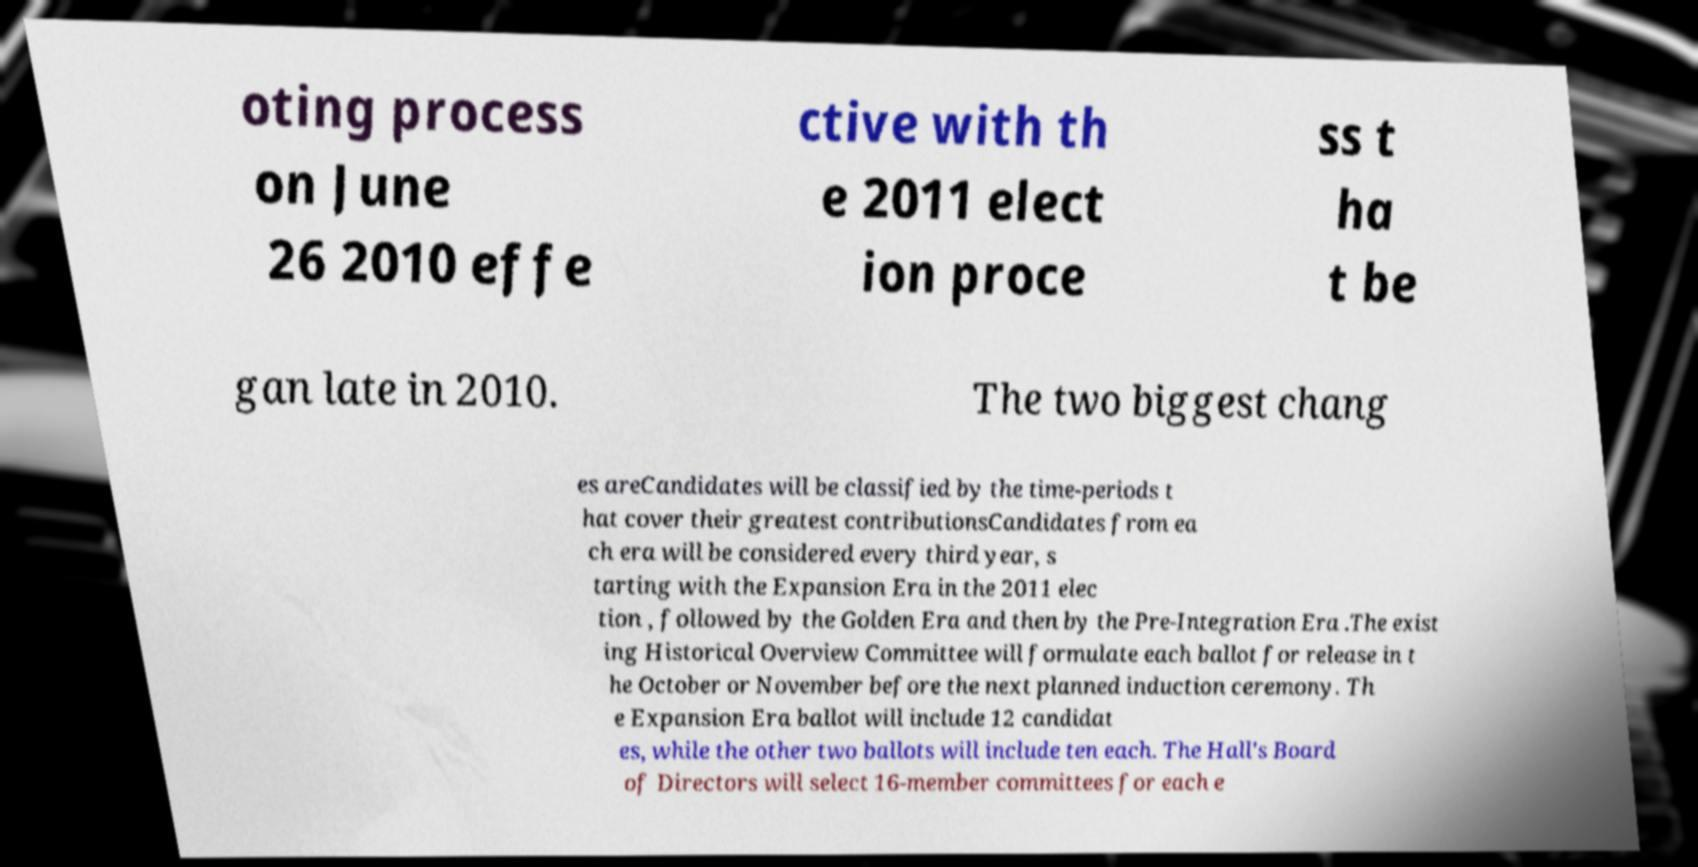Please identify and transcribe the text found in this image. oting process on June 26 2010 effe ctive with th e 2011 elect ion proce ss t ha t be gan late in 2010. The two biggest chang es areCandidates will be classified by the time-periods t hat cover their greatest contributionsCandidates from ea ch era will be considered every third year, s tarting with the Expansion Era in the 2011 elec tion , followed by the Golden Era and then by the Pre-Integration Era .The exist ing Historical Overview Committee will formulate each ballot for release in t he October or November before the next planned induction ceremony. Th e Expansion Era ballot will include 12 candidat es, while the other two ballots will include ten each. The Hall's Board of Directors will select 16-member committees for each e 